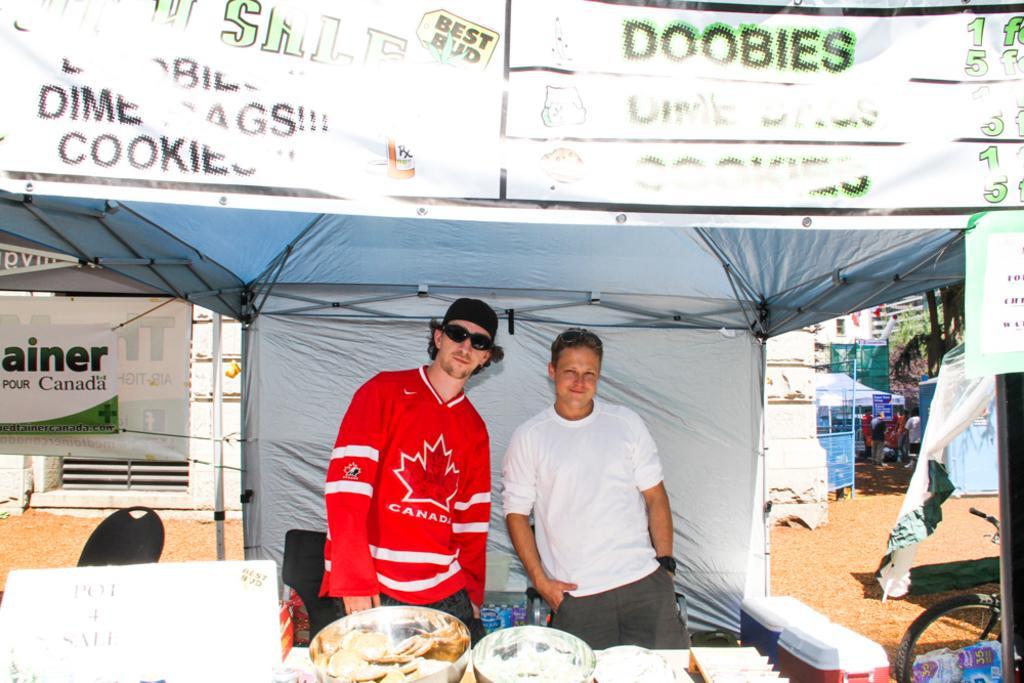How would you summarize this image in a sentence or two? In this picture there are two men in the center of the image, in a stall and there are other stalls on the right and left side of the image and there is a poster at the top side of the image, there are cookies in the bowls at the bottom side of the image. 